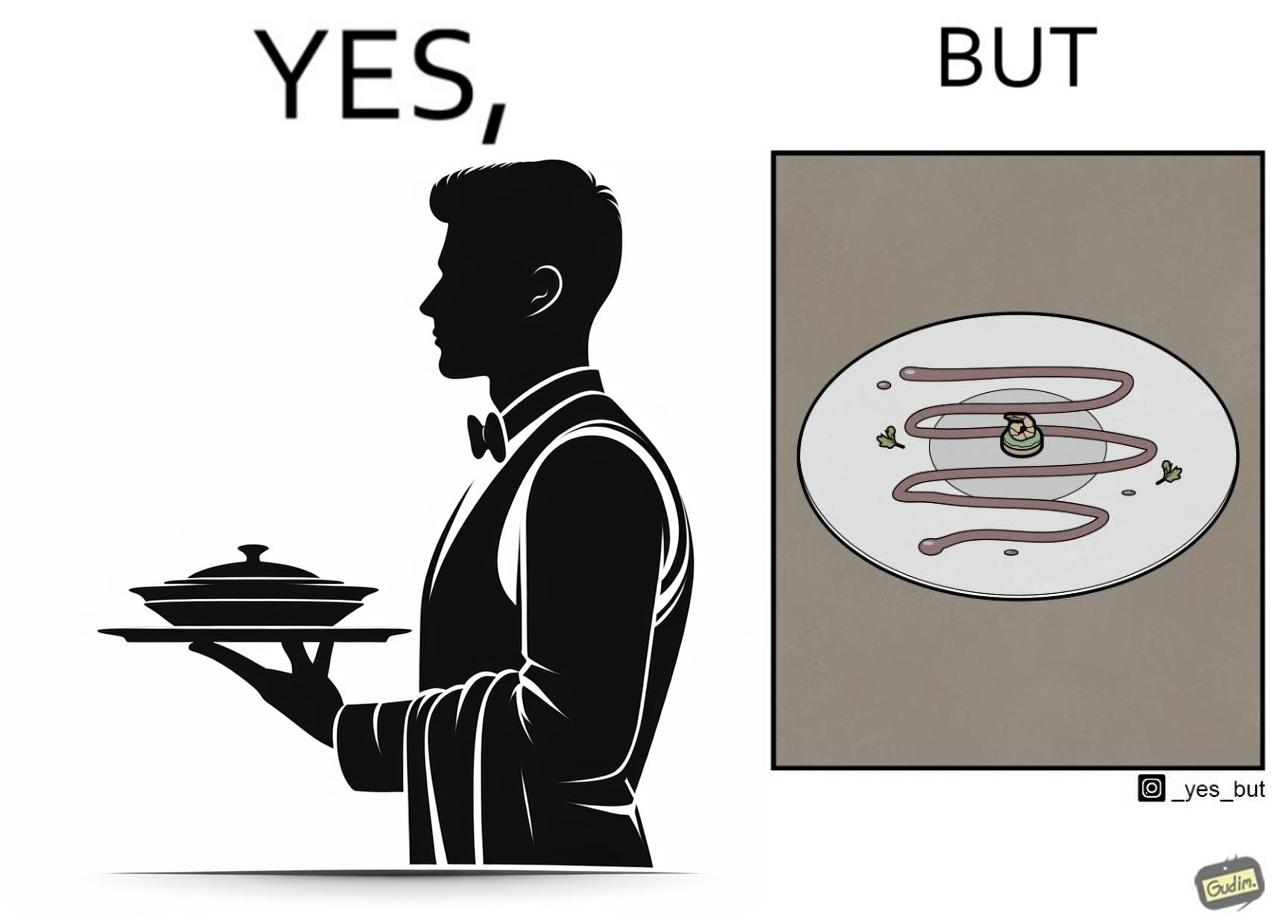Does this image contain satire or humor? Yes, this image is satirical. 